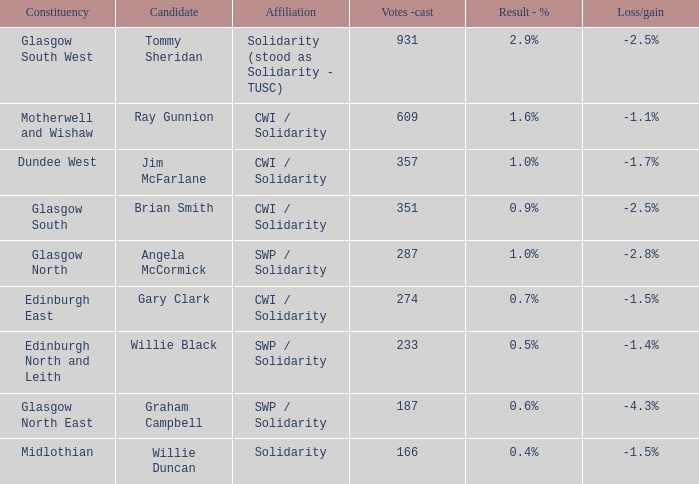What was the loss/gain when the votes -cast was 166? -1.5%. 